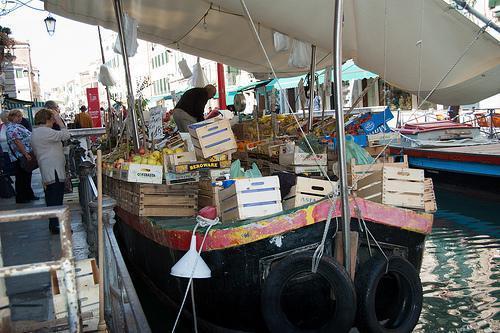How many people are on the boat on the left?
Give a very brief answer. 1. 